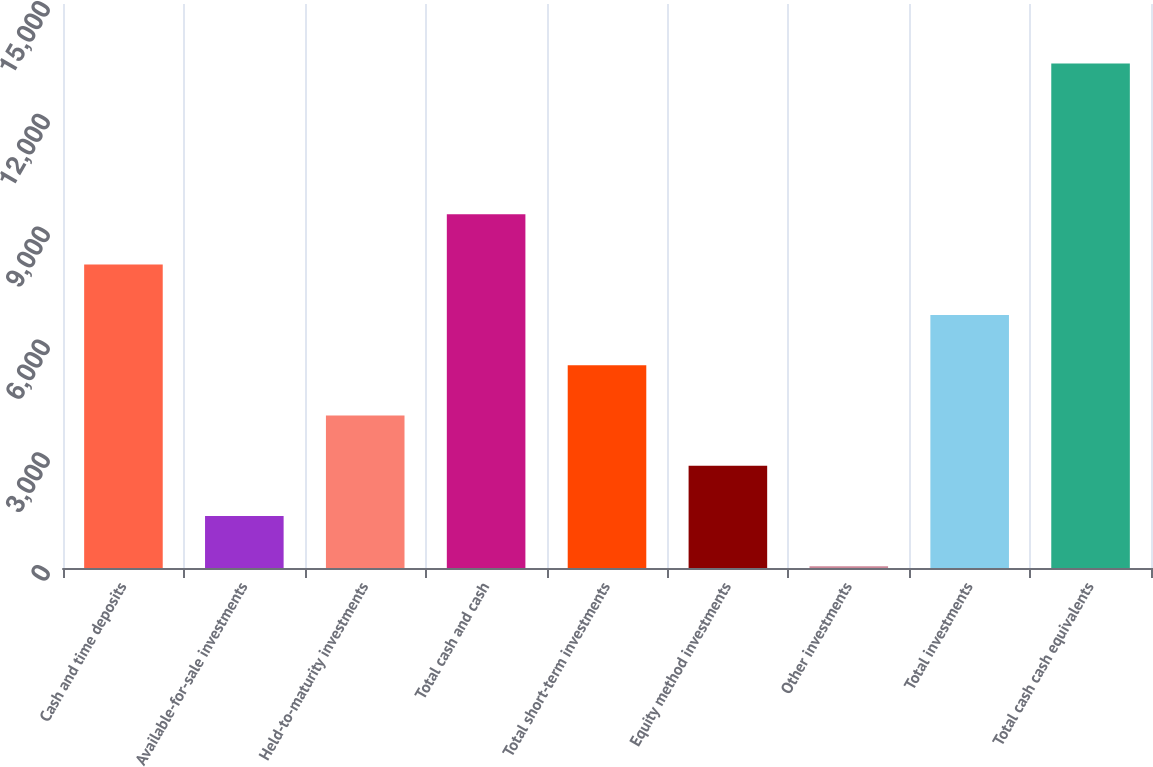<chart> <loc_0><loc_0><loc_500><loc_500><bar_chart><fcel>Cash and time deposits<fcel>Available-for-sale investments<fcel>Held-to-maturity investments<fcel>Total cash and cash<fcel>Total short-term investments<fcel>Equity method investments<fcel>Other investments<fcel>Total investments<fcel>Total cash cash equivalents<nl><fcel>8069<fcel>1381.5<fcel>4056.5<fcel>9406.5<fcel>5394<fcel>2719<fcel>44<fcel>6731.5<fcel>13419<nl></chart> 